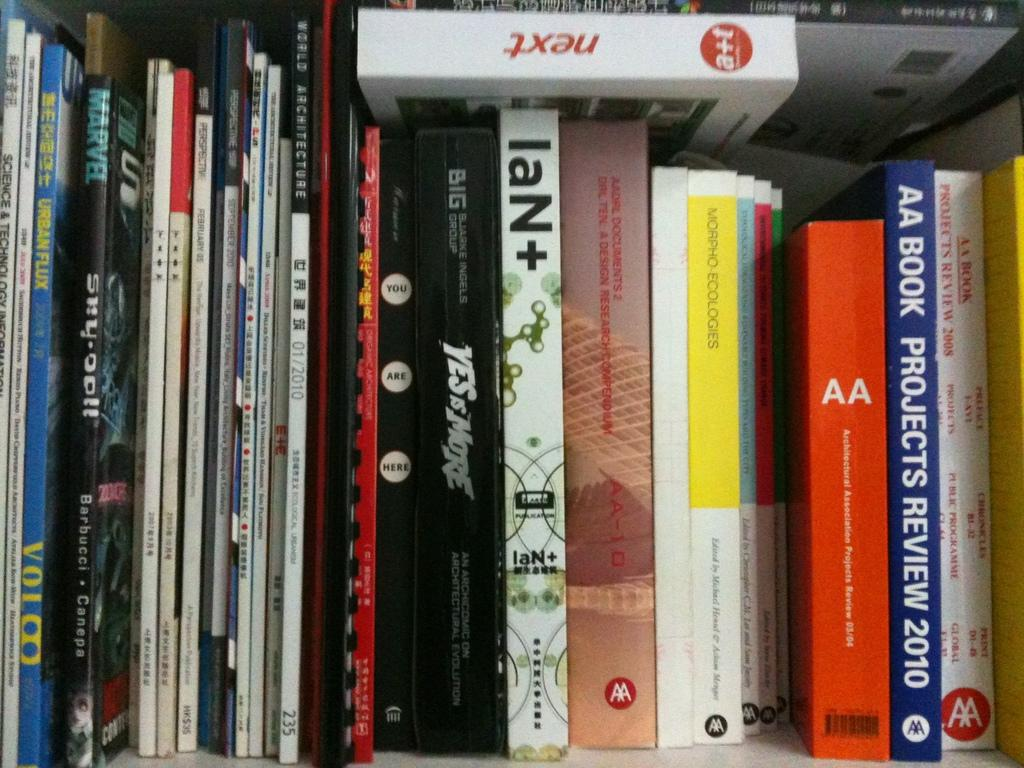Provide a one-sentence caption for the provided image. A book collection including Projects Review 2010 among others. 